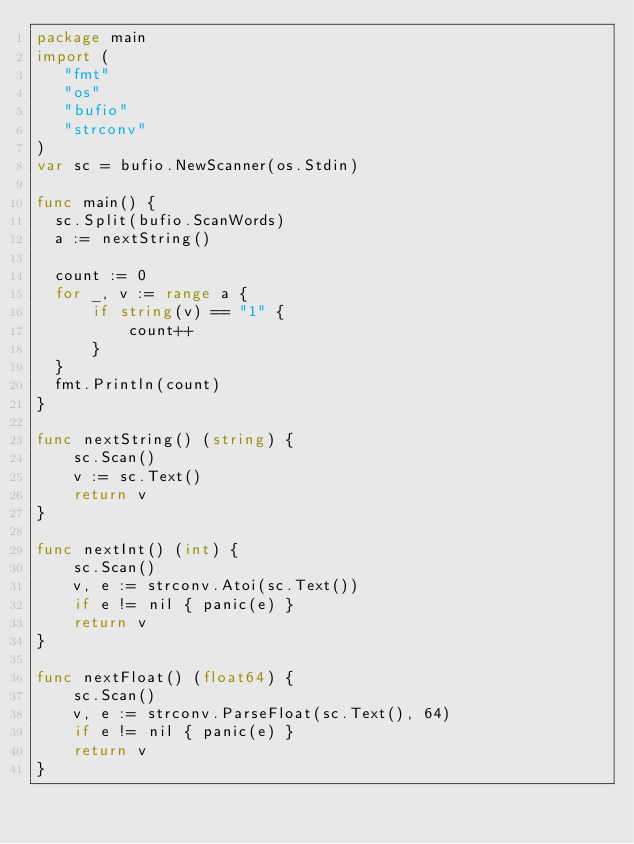Convert code to text. <code><loc_0><loc_0><loc_500><loc_500><_Go_>package main
import (
   "fmt"
   "os"
   "bufio"
   "strconv"
)
var sc = bufio.NewScanner(os.Stdin)

func main() {
  sc.Split(bufio.ScanWords)
  a := nextString()

  count := 0
  for _, v := range a {
	  if string(v) == "1" {
		  count++
	  }
  }
  fmt.Println(count)
}

func nextString() (string) {
	sc.Scan()
	v := sc.Text()
	return v
}

func nextInt() (int) {
	sc.Scan()
	v, e := strconv.Atoi(sc.Text())
    if e != nil { panic(e) }
    return v
}

func nextFloat() (float64) {
	sc.Scan()
	v, e := strconv.ParseFloat(sc.Text(), 64)
    if e != nil { panic(e) }
    return v
}
</code> 